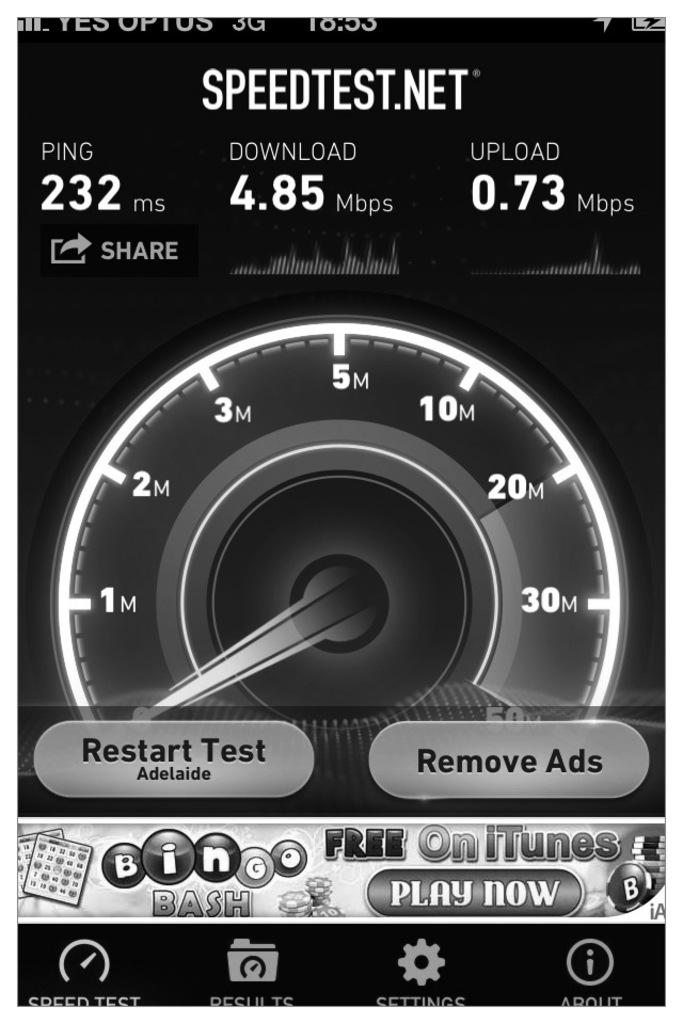What is the main object in the center of the image? There is a speed meter in the center of the image. What can be seen at the top of the image? There is text at the top of the image. What can be seen at the bottom of the image? There is text at the bottom of the image. How many wrens are perched on the speed meter in the image? There are no wrens present in the image; it only features a speed meter and text. What type of stick is used to twist the speed meter in the image? There is no stick or twisting motion involved with the speed meter in the image; it is a static object. 